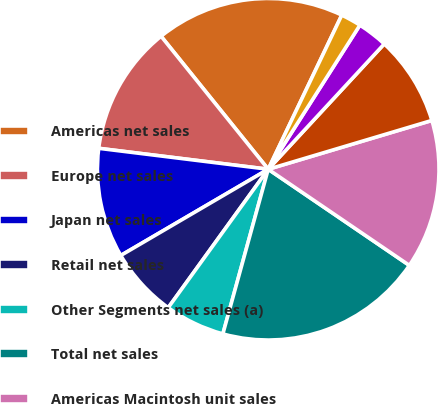<chart> <loc_0><loc_0><loc_500><loc_500><pie_chart><fcel>Americas net sales<fcel>Europe net sales<fcel>Japan net sales<fcel>Retail net sales<fcel>Other Segments net sales (a)<fcel>Total net sales<fcel>Americas Macintosh unit sales<fcel>Europe Macintosh unit sales<fcel>Japan Macintosh unit sales<fcel>Retail Macintosh unit sales<nl><fcel>17.88%<fcel>12.25%<fcel>10.38%<fcel>6.62%<fcel>5.68%<fcel>19.76%<fcel>14.13%<fcel>8.5%<fcel>2.87%<fcel>1.93%<nl></chart> 